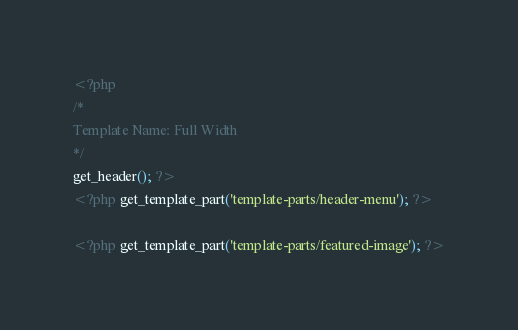Convert code to text. <code><loc_0><loc_0><loc_500><loc_500><_PHP_><?php
/*
Template Name: Full Width
*/
get_header(); ?>
<?php get_template_part('template-parts/header-menu'); ?>

<?php get_template_part('template-parts/featured-image'); ?></code> 